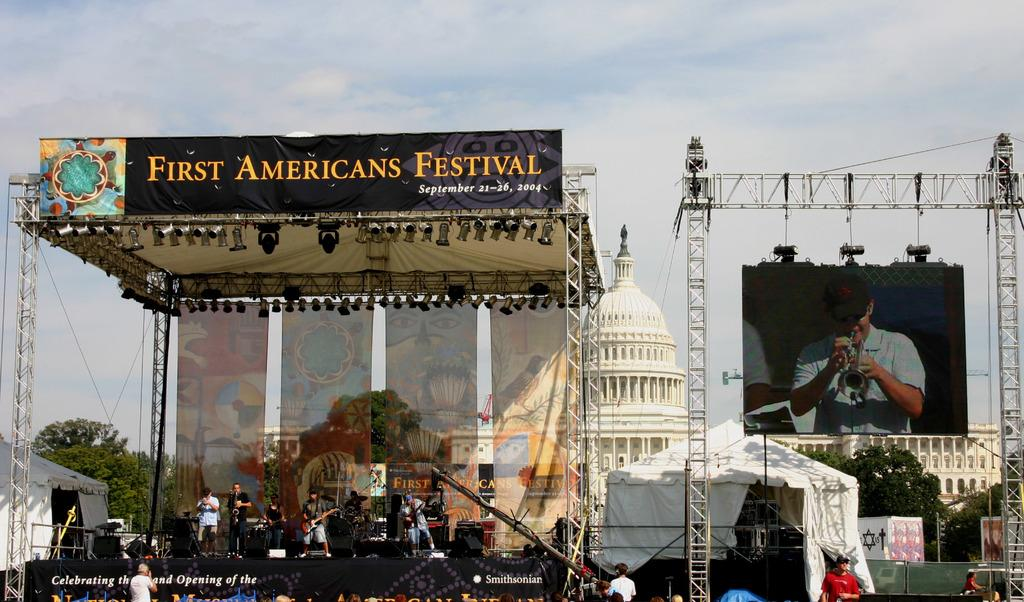Provide a one-sentence caption for the provided image. The stage at the First Americans Festival from 2004 with a projector image of the singer off to the side. 